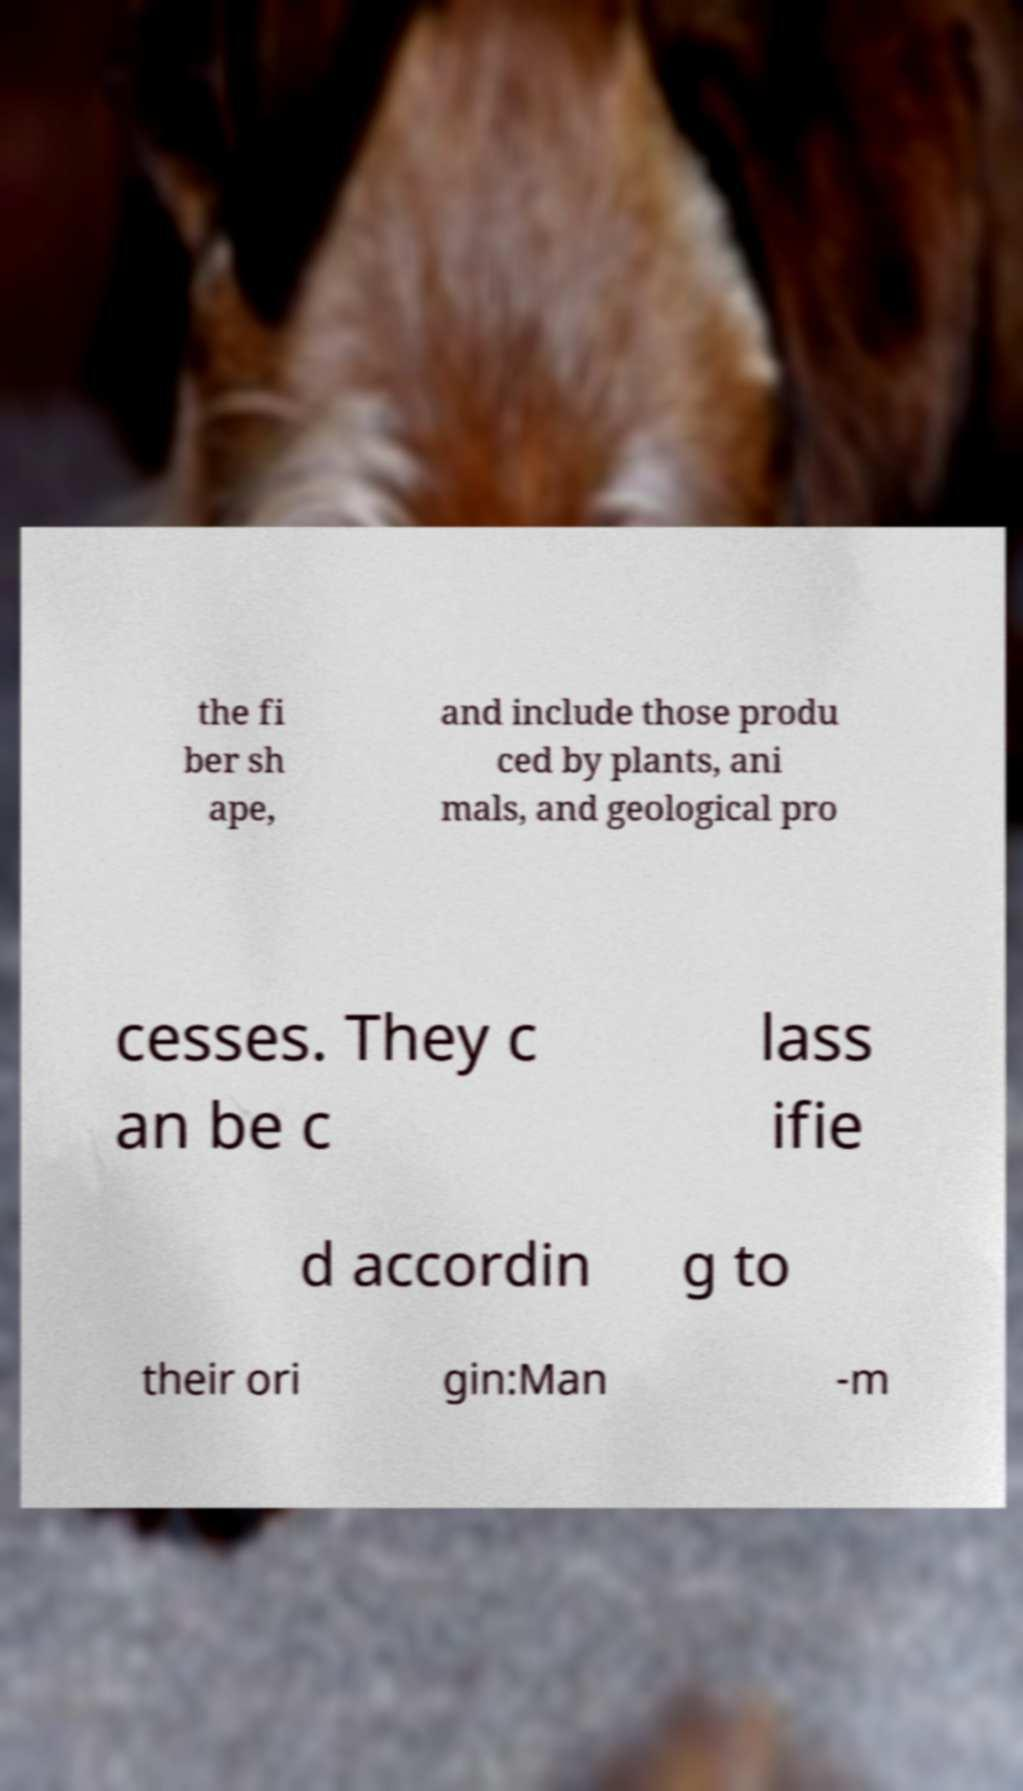Can you accurately transcribe the text from the provided image for me? the fi ber sh ape, and include those produ ced by plants, ani mals, and geological pro cesses. They c an be c lass ifie d accordin g to their ori gin:Man -m 